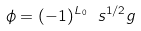Convert formula to latex. <formula><loc_0><loc_0><loc_500><loc_500>\phi = ( - 1 ) ^ { L _ { 0 } } \ s ^ { 1 / 2 } g</formula> 